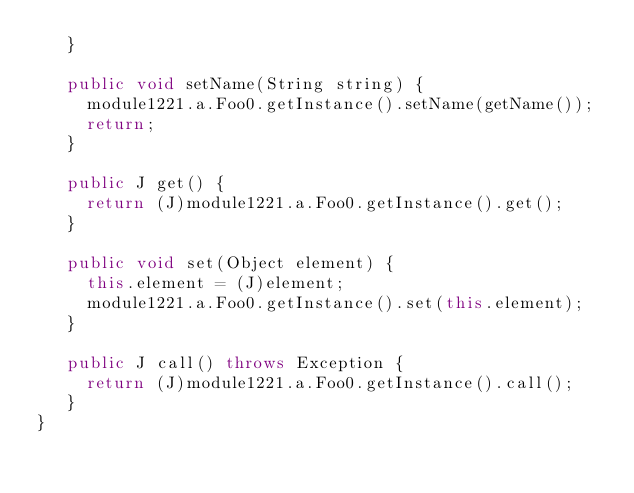Convert code to text. <code><loc_0><loc_0><loc_500><loc_500><_Java_>	 }

	 public void setName(String string) {
	 	 module1221.a.Foo0.getInstance().setName(getName());
	 	 return;
	 }

	 public J get() {
	 	 return (J)module1221.a.Foo0.getInstance().get();
	 }

	 public void set(Object element) {
	 	 this.element = (J)element;
	 	 module1221.a.Foo0.getInstance().set(this.element);
	 }

	 public J call() throws Exception {
	 	 return (J)module1221.a.Foo0.getInstance().call();
	 }
}
</code> 